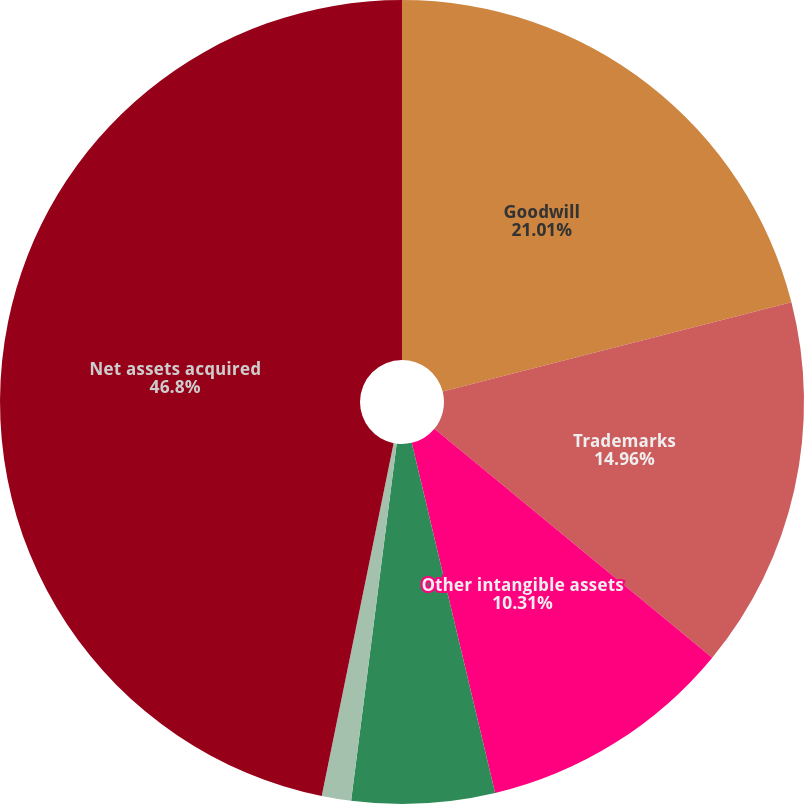Convert chart to OTSL. <chart><loc_0><loc_0><loc_500><loc_500><pie_chart><fcel>Goodwill<fcel>Trademarks<fcel>Other intangible assets<fcel>Other assets primarily current<fcel>Current liabilities<fcel>Net assets acquired<nl><fcel>21.01%<fcel>14.96%<fcel>10.31%<fcel>5.74%<fcel>1.18%<fcel>46.8%<nl></chart> 